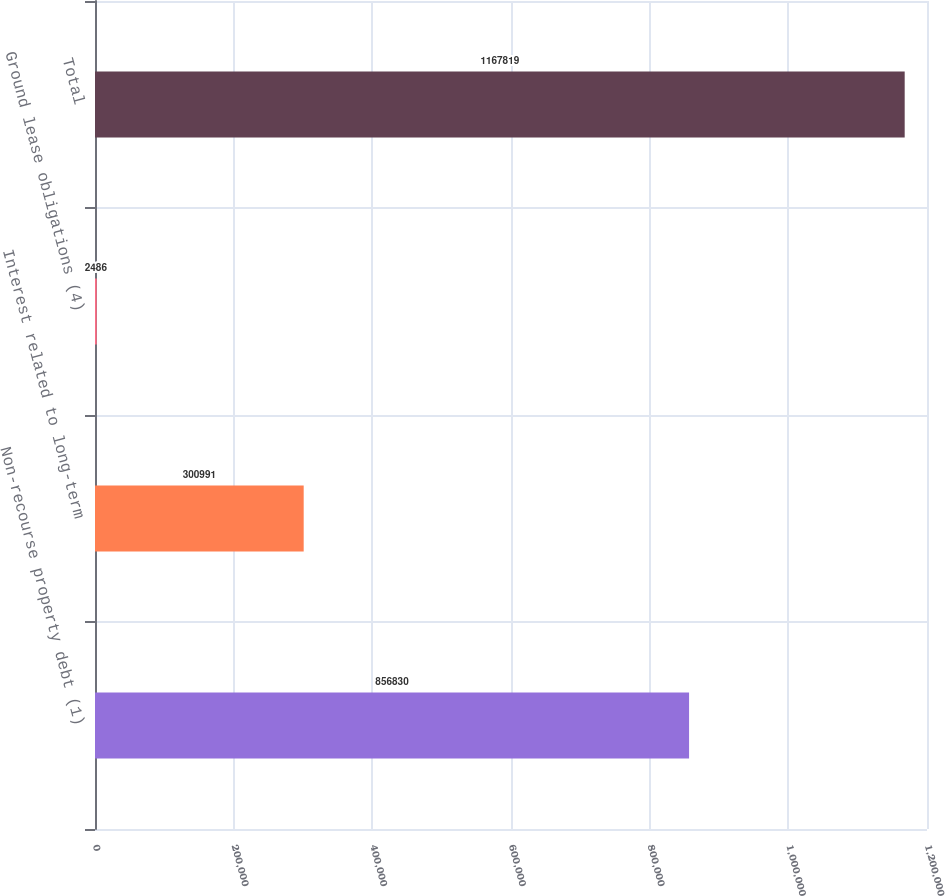<chart> <loc_0><loc_0><loc_500><loc_500><bar_chart><fcel>Non-recourse property debt (1)<fcel>Interest related to long-term<fcel>Ground lease obligations (4)<fcel>Total<nl><fcel>856830<fcel>300991<fcel>2486<fcel>1.16782e+06<nl></chart> 